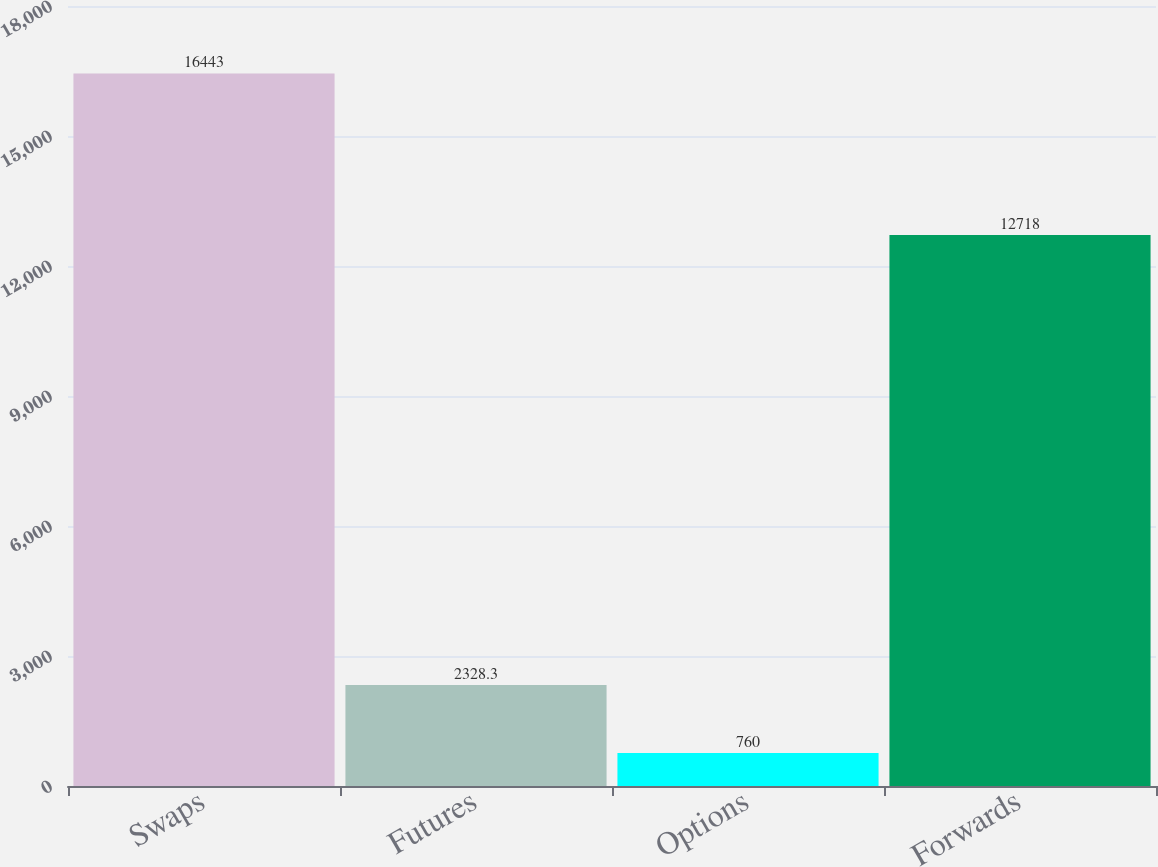Convert chart. <chart><loc_0><loc_0><loc_500><loc_500><bar_chart><fcel>Swaps<fcel>Futures<fcel>Options<fcel>Forwards<nl><fcel>16443<fcel>2328.3<fcel>760<fcel>12718<nl></chart> 